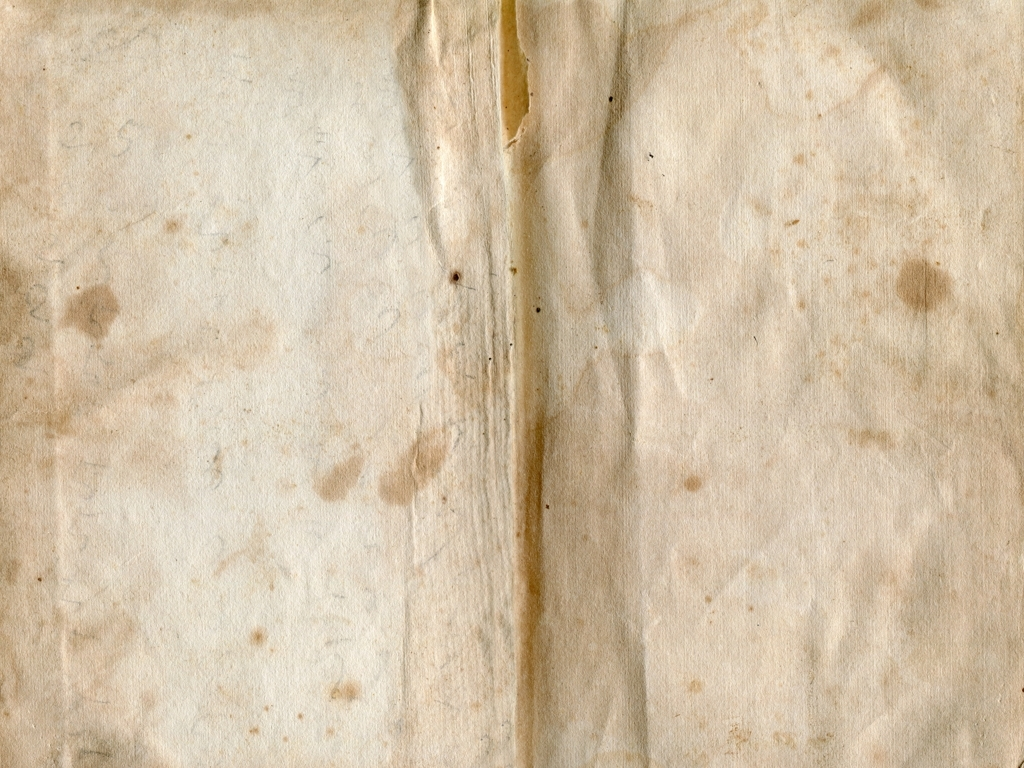Is the main subject easily recognizable? Given the image provided appears to be a blank piece of aged paper with no distinct main subject, it is accurate to say that there is no easily recognizable main subject. The texture and color variation of the paper could imply historical context or could be used as a background for an artistic composition. 